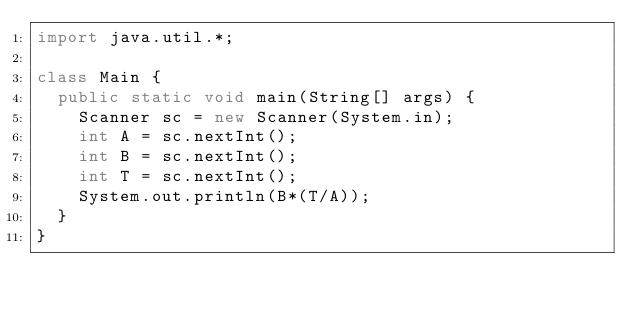<code> <loc_0><loc_0><loc_500><loc_500><_Java_>import java.util.*;

class Main {
	public static void main(String[] args) {
		Scanner sc = new Scanner(System.in);
		int A = sc.nextInt();
		int B = sc.nextInt();
		int T = sc.nextInt();
		System.out.println(B*(T/A));
	}
}</code> 